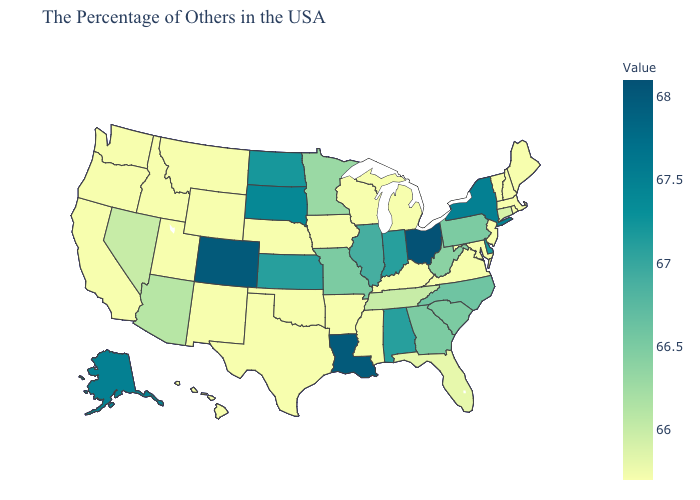Does Pennsylvania have the lowest value in the USA?
Quick response, please. No. Among the states that border West Virginia , does Ohio have the highest value?
Write a very short answer. Yes. Does the map have missing data?
Quick response, please. No. Which states have the lowest value in the USA?
Short answer required. Maine, Massachusetts, Rhode Island, New Hampshire, Vermont, New Jersey, Maryland, Virginia, Michigan, Kentucky, Wisconsin, Mississippi, Arkansas, Iowa, Nebraska, Oklahoma, Texas, Wyoming, New Mexico, Utah, Montana, Idaho, California, Washington, Oregon, Hawaii. Which states have the lowest value in the South?
Answer briefly. Maryland, Virginia, Kentucky, Mississippi, Arkansas, Oklahoma, Texas. Does Ohio have the highest value in the MidWest?
Keep it brief. Yes. 